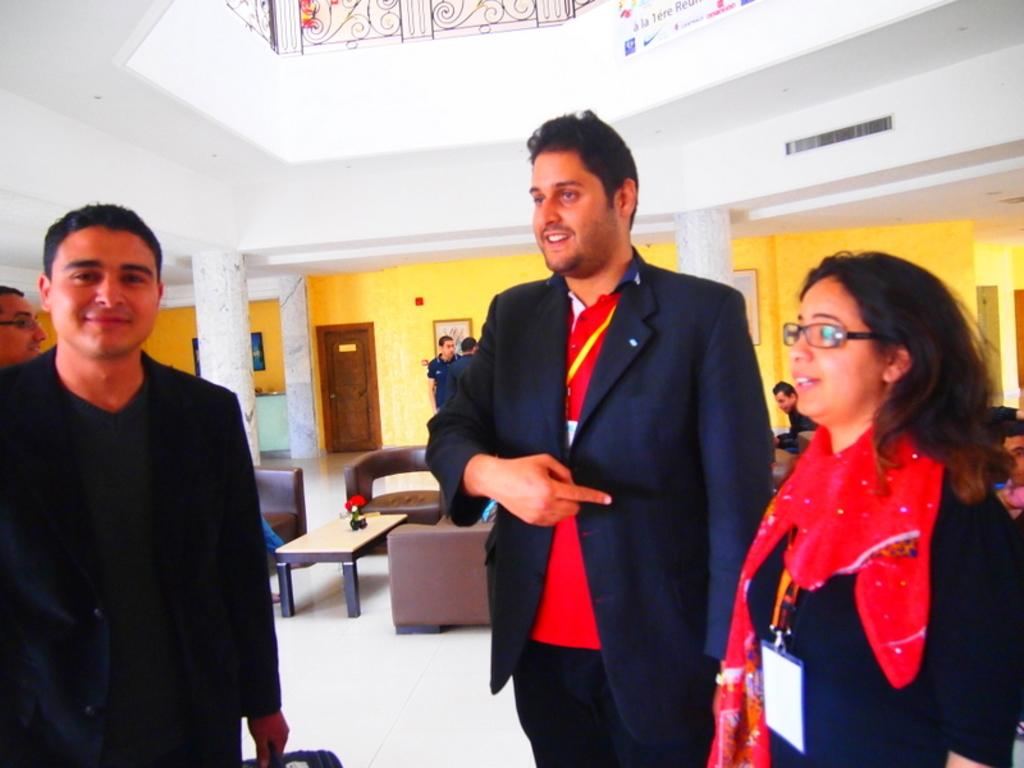What are the people in the image doing? The people in the image are standing on the floor and smiling. What can be seen in the background of the image? In the background of the image, there are chairs, a table, a door, pillars, and frames on the wall. Can you describe the setting of the image? The image appears to be set in a room with a floor, background elements, and people standing and smiling. What is the reason behind the people's decision to rest on the view in the image? There is no indication in the image that the people are resting or that there is a view to rest on. 